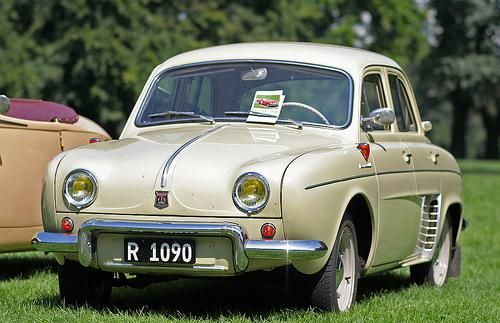What sort of event might this car be displayed at? The car could be displayed at a vintage car show or a classic auto exhibition, events that celebrate and showcase antique and historically significant vehicles. 